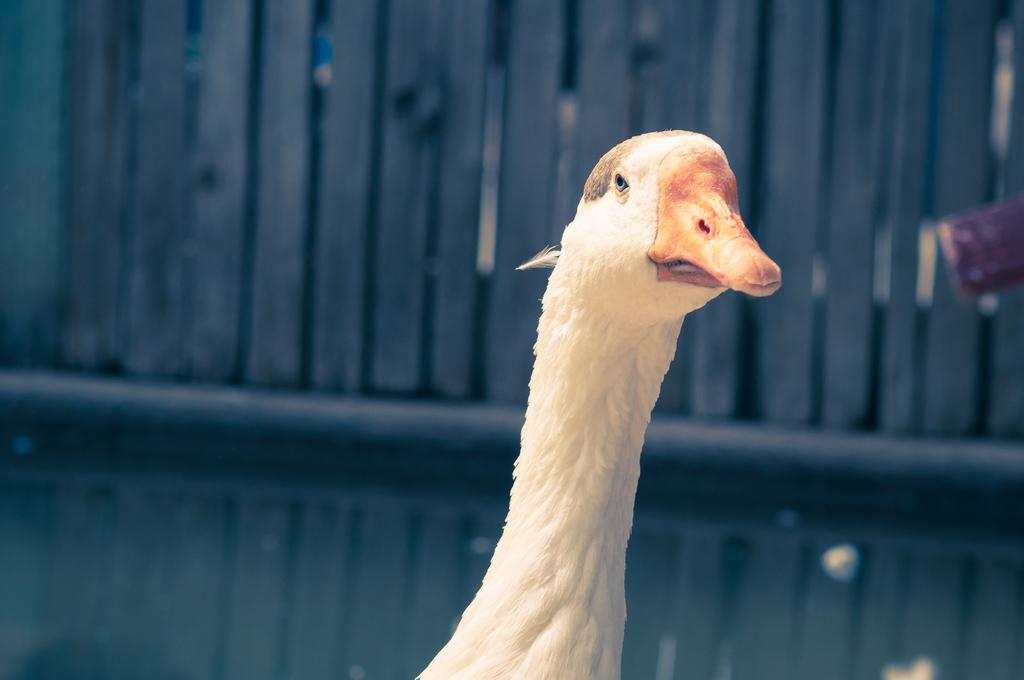What animal can be seen in the picture? There is a goose in the picture. What can be seen in the background of the picture? There is a fence in the background of the picture. What route does the van take in the picture? There is no van present in the picture, so it is not possible to determine a route. 